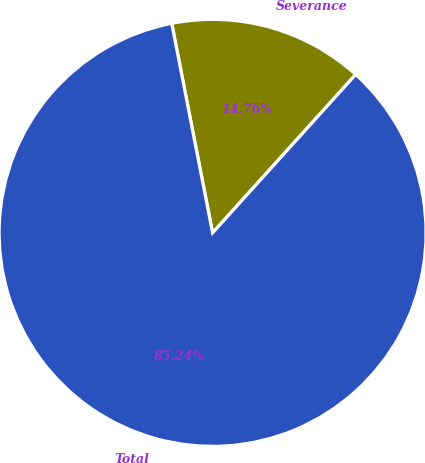Convert chart. <chart><loc_0><loc_0><loc_500><loc_500><pie_chart><fcel>Severance<fcel>Total<nl><fcel>14.76%<fcel>85.24%<nl></chart> 